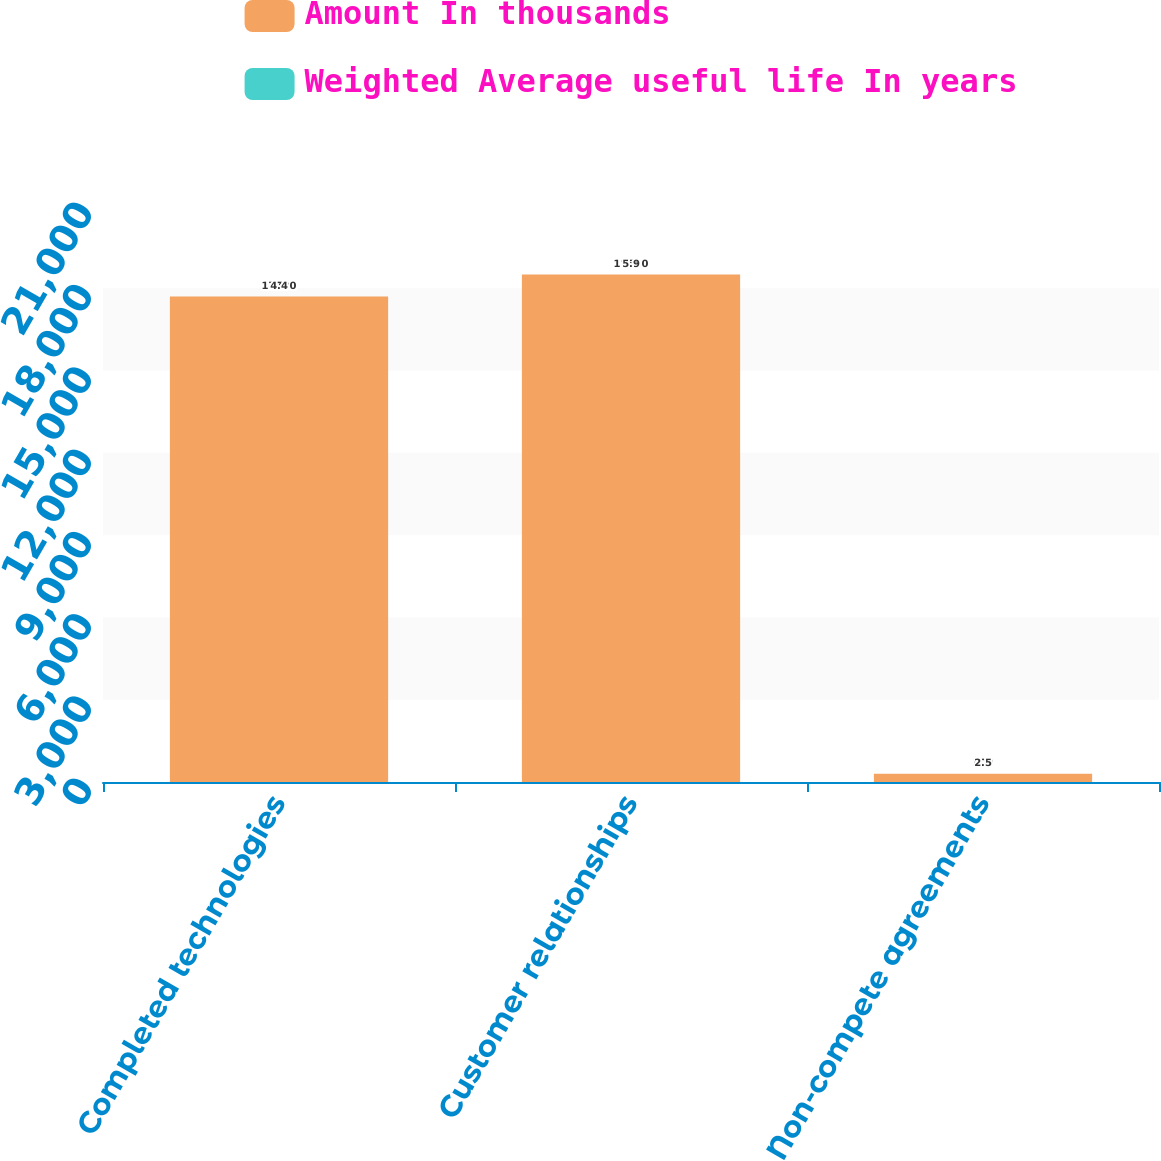<chart> <loc_0><loc_0><loc_500><loc_500><stacked_bar_chart><ecel><fcel>Completed technologies<fcel>Customer relationships<fcel>Non-compete agreements<nl><fcel>Amount In thousands<fcel>17700<fcel>18500<fcel>300<nl><fcel>Weighted Average useful life In years<fcel>4.4<fcel>5.9<fcel>2.5<nl></chart> 